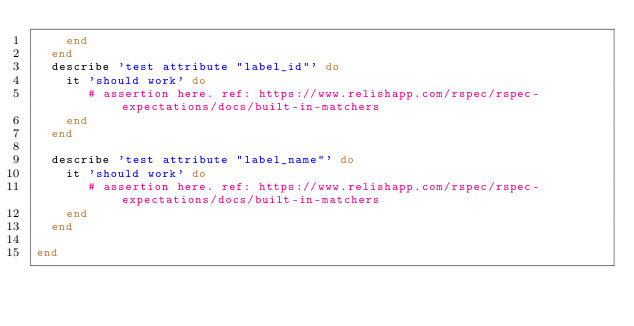Convert code to text. <code><loc_0><loc_0><loc_500><loc_500><_Ruby_>    end
  end
  describe 'test attribute "label_id"' do
    it 'should work' do
       # assertion here. ref: https://www.relishapp.com/rspec/rspec-expectations/docs/built-in-matchers
    end
  end

  describe 'test attribute "label_name"' do
    it 'should work' do
       # assertion here. ref: https://www.relishapp.com/rspec/rspec-expectations/docs/built-in-matchers
    end
  end

end

</code> 